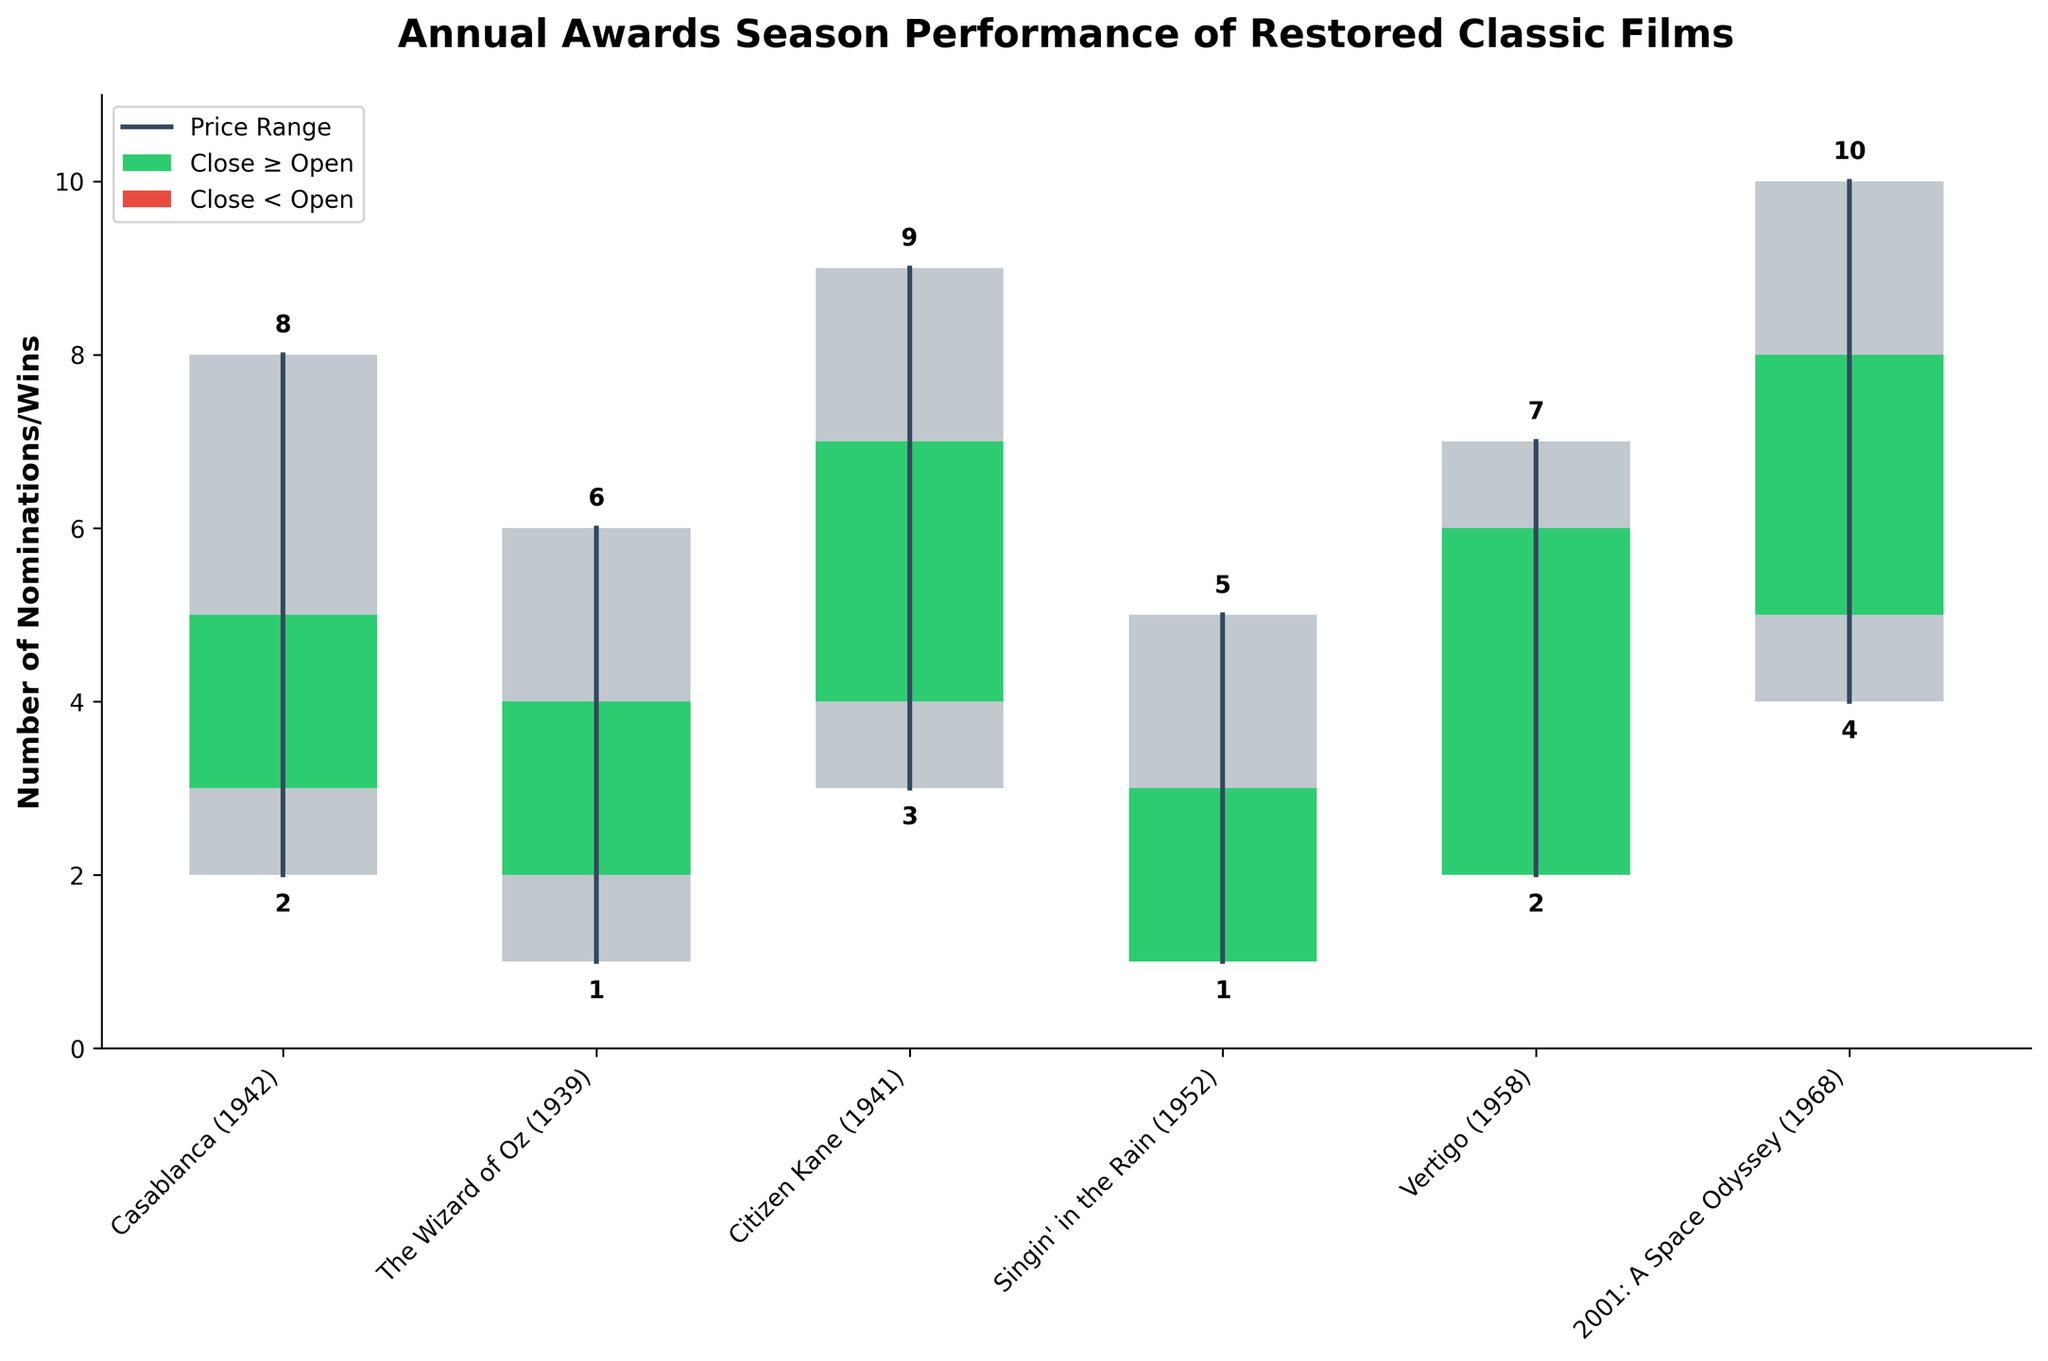What is the title of the figure? The title of the figure is written at the top of the plot and provides an overview of what the chart represents. Looking at the figure, it says "Annual Awards Season Performance of Restored Classic Films".
Answer: Annual Awards Season Performance of Restored Classic Films Which film had the highest range between nominations and wins? To find the film with the highest range, calculate the difference between the High and Low values for each film and compare them. For "2001: A Space Odyssey (1968)", the range is 10 - 4 = 6, which is the highest among the films.
Answer: 2001: A Space Odyssey (1968) How many films closed higher than they opened? Count the films where the Close value is greater than the Open value. The films that meet this criterion are "Casablanca (1942)", "Citizen Kane (1941)", "Vertigo (1958)", and "2001: A Space Odyssey (1968)"—totaling 4 films.
Answer: 4 What is the lowest number of nominations or wins recorded by any film? Look at the Low values for each film and find the minimum value. The lowest Low recorded is 1, seen in "The Wizard of Oz (1939)" and "Singin' in the Rain (1952)".
Answer: 1 Which film had the largest increase from its Open value to its Close value? Calculate the difference between Close and Open values for each film and find the film with the largest positive difference. "Citizen Kane (1941)" had the largest increase, going from 4 to 7 (difference of 3).
Answer: Citizen Kane (1941) How many films had the same number of openings as closures? Find the films where the Open and Close values are equal. There are no films in the dataset that meet this criterion.
Answer: 0 Which film had the highest Close value? Look at the Close values for each film and identify the maximum value. "2001: A Space Odyssey (1968)" has the highest Close value of 8.
Answer: 2001: A Space Odyssey (1968) What is the average High value across all films? To find the average, sum up all the High values and divide by the number of films. Sum of High values = 8 + 6 + 9 + 5 + 7 + 10 = 45. There are 6 films, so the average High value is 45 / 6 = 7.5.
Answer: 7.5 Which film had the smallest difference between its High and Low values? Calculate the range (High - Low) for each film and find the smallest range. Both "Singin' in the Rain (1952)" and "Vertigo (1958)" have a range of 5 - 1 = 4 and 7 - 2 = 5, respectively. The smallest difference is 4 for "Singin' in the Rain (1952)".
Answer: Singin' in the Rain (1952) 